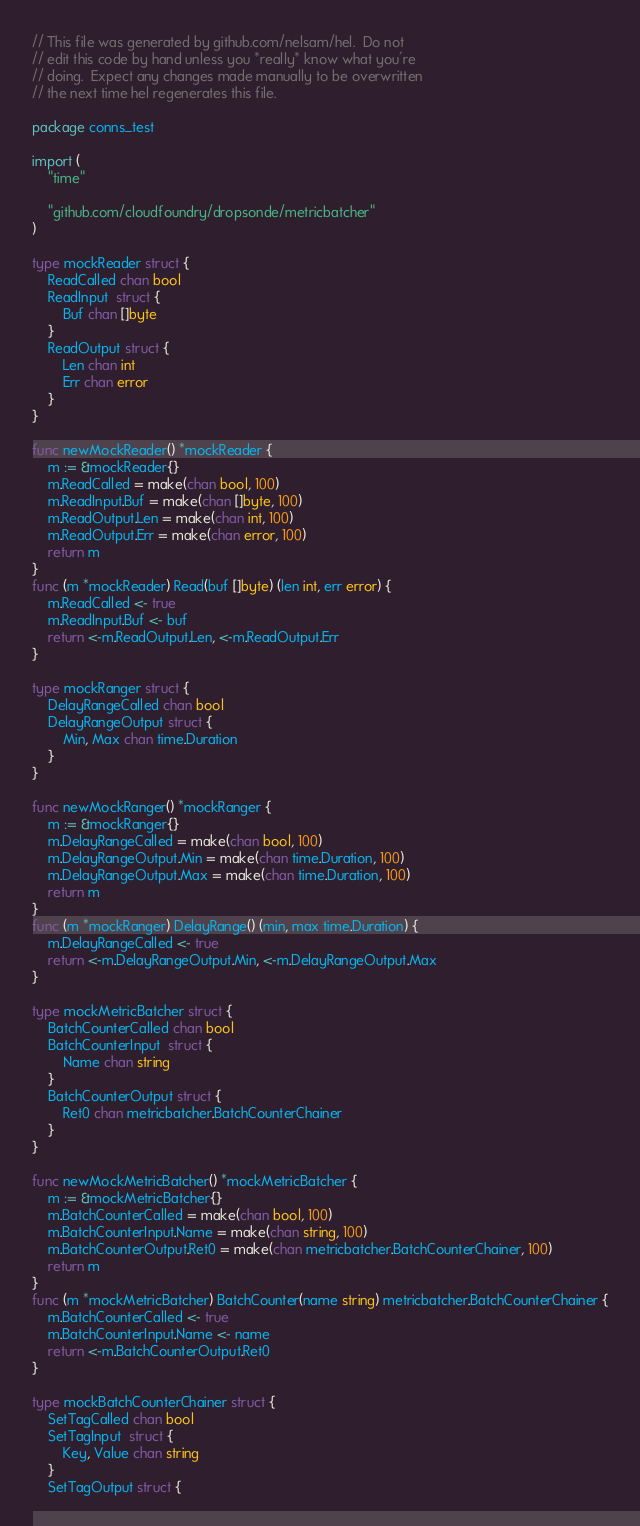Convert code to text. <code><loc_0><loc_0><loc_500><loc_500><_Go_>// This file was generated by github.com/nelsam/hel.  Do not
// edit this code by hand unless you *really* know what you're
// doing.  Expect any changes made manually to be overwritten
// the next time hel regenerates this file.

package conns_test

import (
	"time"

	"github.com/cloudfoundry/dropsonde/metricbatcher"
)

type mockReader struct {
	ReadCalled chan bool
	ReadInput  struct {
		Buf chan []byte
	}
	ReadOutput struct {
		Len chan int
		Err chan error
	}
}

func newMockReader() *mockReader {
	m := &mockReader{}
	m.ReadCalled = make(chan bool, 100)
	m.ReadInput.Buf = make(chan []byte, 100)
	m.ReadOutput.Len = make(chan int, 100)
	m.ReadOutput.Err = make(chan error, 100)
	return m
}
func (m *mockReader) Read(buf []byte) (len int, err error) {
	m.ReadCalled <- true
	m.ReadInput.Buf <- buf
	return <-m.ReadOutput.Len, <-m.ReadOutput.Err
}

type mockRanger struct {
	DelayRangeCalled chan bool
	DelayRangeOutput struct {
		Min, Max chan time.Duration
	}
}

func newMockRanger() *mockRanger {
	m := &mockRanger{}
	m.DelayRangeCalled = make(chan bool, 100)
	m.DelayRangeOutput.Min = make(chan time.Duration, 100)
	m.DelayRangeOutput.Max = make(chan time.Duration, 100)
	return m
}
func (m *mockRanger) DelayRange() (min, max time.Duration) {
	m.DelayRangeCalled <- true
	return <-m.DelayRangeOutput.Min, <-m.DelayRangeOutput.Max
}

type mockMetricBatcher struct {
	BatchCounterCalled chan bool
	BatchCounterInput  struct {
		Name chan string
	}
	BatchCounterOutput struct {
		Ret0 chan metricbatcher.BatchCounterChainer
	}
}

func newMockMetricBatcher() *mockMetricBatcher {
	m := &mockMetricBatcher{}
	m.BatchCounterCalled = make(chan bool, 100)
	m.BatchCounterInput.Name = make(chan string, 100)
	m.BatchCounterOutput.Ret0 = make(chan metricbatcher.BatchCounterChainer, 100)
	return m
}
func (m *mockMetricBatcher) BatchCounter(name string) metricbatcher.BatchCounterChainer {
	m.BatchCounterCalled <- true
	m.BatchCounterInput.Name <- name
	return <-m.BatchCounterOutput.Ret0
}

type mockBatchCounterChainer struct {
	SetTagCalled chan bool
	SetTagInput  struct {
		Key, Value chan string
	}
	SetTagOutput struct {</code> 